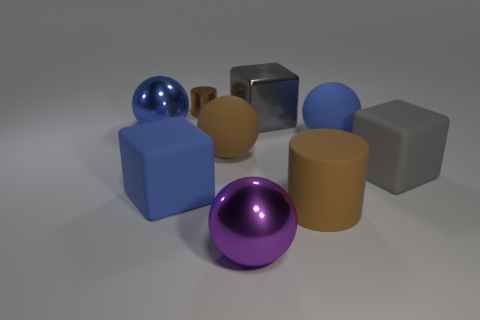Subtract all cubes. How many objects are left? 6 Add 3 blue metal balls. How many blue metal balls exist? 4 Subtract 0 yellow blocks. How many objects are left? 9 Subtract all large cylinders. Subtract all blue metal things. How many objects are left? 7 Add 6 big gray objects. How many big gray objects are left? 8 